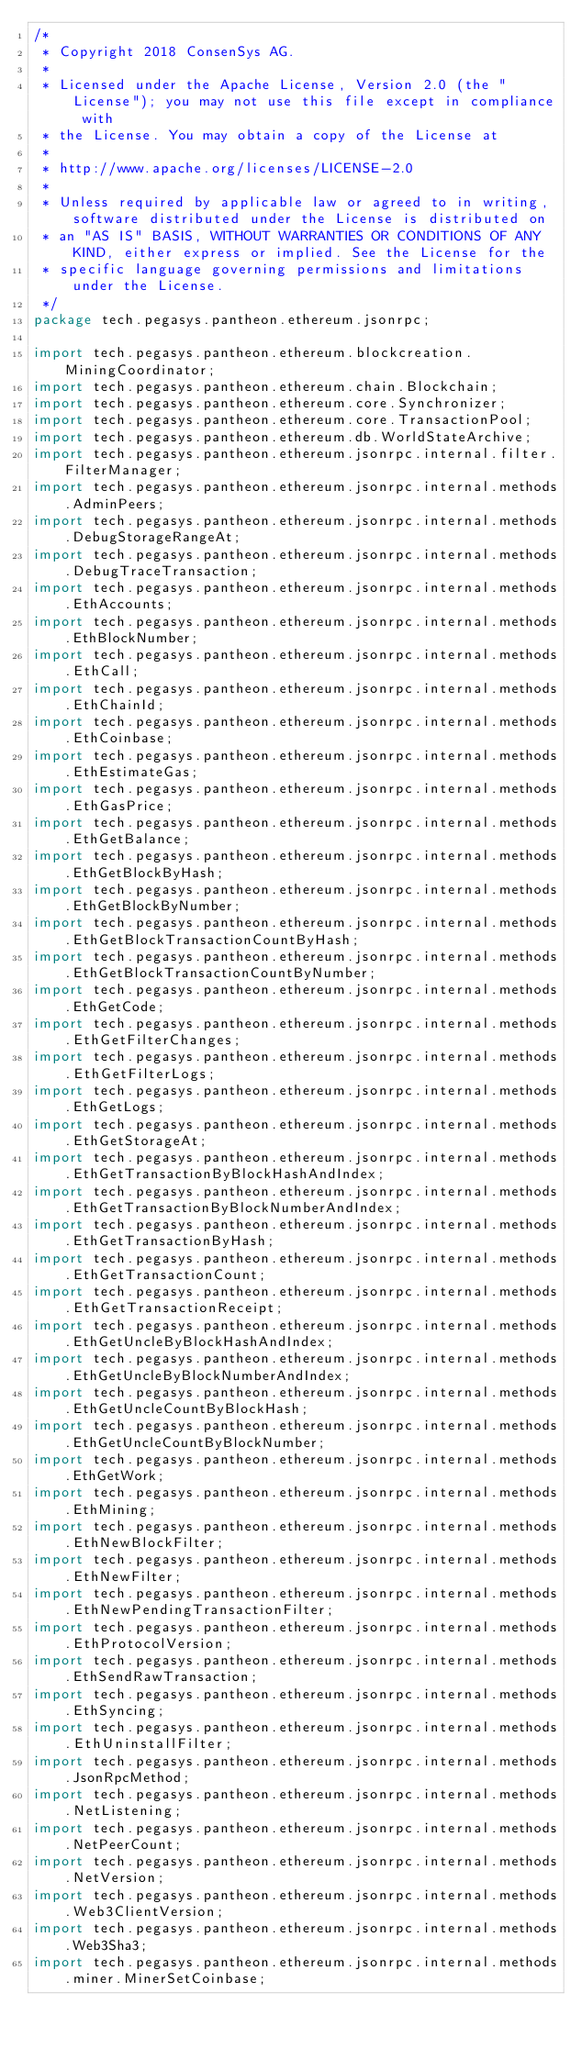<code> <loc_0><loc_0><loc_500><loc_500><_Java_>/*
 * Copyright 2018 ConsenSys AG.
 *
 * Licensed under the Apache License, Version 2.0 (the "License"); you may not use this file except in compliance with
 * the License. You may obtain a copy of the License at
 *
 * http://www.apache.org/licenses/LICENSE-2.0
 *
 * Unless required by applicable law or agreed to in writing, software distributed under the License is distributed on
 * an "AS IS" BASIS, WITHOUT WARRANTIES OR CONDITIONS OF ANY KIND, either express or implied. See the License for the
 * specific language governing permissions and limitations under the License.
 */
package tech.pegasys.pantheon.ethereum.jsonrpc;

import tech.pegasys.pantheon.ethereum.blockcreation.MiningCoordinator;
import tech.pegasys.pantheon.ethereum.chain.Blockchain;
import tech.pegasys.pantheon.ethereum.core.Synchronizer;
import tech.pegasys.pantheon.ethereum.core.TransactionPool;
import tech.pegasys.pantheon.ethereum.db.WorldStateArchive;
import tech.pegasys.pantheon.ethereum.jsonrpc.internal.filter.FilterManager;
import tech.pegasys.pantheon.ethereum.jsonrpc.internal.methods.AdminPeers;
import tech.pegasys.pantheon.ethereum.jsonrpc.internal.methods.DebugStorageRangeAt;
import tech.pegasys.pantheon.ethereum.jsonrpc.internal.methods.DebugTraceTransaction;
import tech.pegasys.pantheon.ethereum.jsonrpc.internal.methods.EthAccounts;
import tech.pegasys.pantheon.ethereum.jsonrpc.internal.methods.EthBlockNumber;
import tech.pegasys.pantheon.ethereum.jsonrpc.internal.methods.EthCall;
import tech.pegasys.pantheon.ethereum.jsonrpc.internal.methods.EthChainId;
import tech.pegasys.pantheon.ethereum.jsonrpc.internal.methods.EthCoinbase;
import tech.pegasys.pantheon.ethereum.jsonrpc.internal.methods.EthEstimateGas;
import tech.pegasys.pantheon.ethereum.jsonrpc.internal.methods.EthGasPrice;
import tech.pegasys.pantheon.ethereum.jsonrpc.internal.methods.EthGetBalance;
import tech.pegasys.pantheon.ethereum.jsonrpc.internal.methods.EthGetBlockByHash;
import tech.pegasys.pantheon.ethereum.jsonrpc.internal.methods.EthGetBlockByNumber;
import tech.pegasys.pantheon.ethereum.jsonrpc.internal.methods.EthGetBlockTransactionCountByHash;
import tech.pegasys.pantheon.ethereum.jsonrpc.internal.methods.EthGetBlockTransactionCountByNumber;
import tech.pegasys.pantheon.ethereum.jsonrpc.internal.methods.EthGetCode;
import tech.pegasys.pantheon.ethereum.jsonrpc.internal.methods.EthGetFilterChanges;
import tech.pegasys.pantheon.ethereum.jsonrpc.internal.methods.EthGetFilterLogs;
import tech.pegasys.pantheon.ethereum.jsonrpc.internal.methods.EthGetLogs;
import tech.pegasys.pantheon.ethereum.jsonrpc.internal.methods.EthGetStorageAt;
import tech.pegasys.pantheon.ethereum.jsonrpc.internal.methods.EthGetTransactionByBlockHashAndIndex;
import tech.pegasys.pantheon.ethereum.jsonrpc.internal.methods.EthGetTransactionByBlockNumberAndIndex;
import tech.pegasys.pantheon.ethereum.jsonrpc.internal.methods.EthGetTransactionByHash;
import tech.pegasys.pantheon.ethereum.jsonrpc.internal.methods.EthGetTransactionCount;
import tech.pegasys.pantheon.ethereum.jsonrpc.internal.methods.EthGetTransactionReceipt;
import tech.pegasys.pantheon.ethereum.jsonrpc.internal.methods.EthGetUncleByBlockHashAndIndex;
import tech.pegasys.pantheon.ethereum.jsonrpc.internal.methods.EthGetUncleByBlockNumberAndIndex;
import tech.pegasys.pantheon.ethereum.jsonrpc.internal.methods.EthGetUncleCountByBlockHash;
import tech.pegasys.pantheon.ethereum.jsonrpc.internal.methods.EthGetUncleCountByBlockNumber;
import tech.pegasys.pantheon.ethereum.jsonrpc.internal.methods.EthGetWork;
import tech.pegasys.pantheon.ethereum.jsonrpc.internal.methods.EthMining;
import tech.pegasys.pantheon.ethereum.jsonrpc.internal.methods.EthNewBlockFilter;
import tech.pegasys.pantheon.ethereum.jsonrpc.internal.methods.EthNewFilter;
import tech.pegasys.pantheon.ethereum.jsonrpc.internal.methods.EthNewPendingTransactionFilter;
import tech.pegasys.pantheon.ethereum.jsonrpc.internal.methods.EthProtocolVersion;
import tech.pegasys.pantheon.ethereum.jsonrpc.internal.methods.EthSendRawTransaction;
import tech.pegasys.pantheon.ethereum.jsonrpc.internal.methods.EthSyncing;
import tech.pegasys.pantheon.ethereum.jsonrpc.internal.methods.EthUninstallFilter;
import tech.pegasys.pantheon.ethereum.jsonrpc.internal.methods.JsonRpcMethod;
import tech.pegasys.pantheon.ethereum.jsonrpc.internal.methods.NetListening;
import tech.pegasys.pantheon.ethereum.jsonrpc.internal.methods.NetPeerCount;
import tech.pegasys.pantheon.ethereum.jsonrpc.internal.methods.NetVersion;
import tech.pegasys.pantheon.ethereum.jsonrpc.internal.methods.Web3ClientVersion;
import tech.pegasys.pantheon.ethereum.jsonrpc.internal.methods.Web3Sha3;
import tech.pegasys.pantheon.ethereum.jsonrpc.internal.methods.miner.MinerSetCoinbase;</code> 